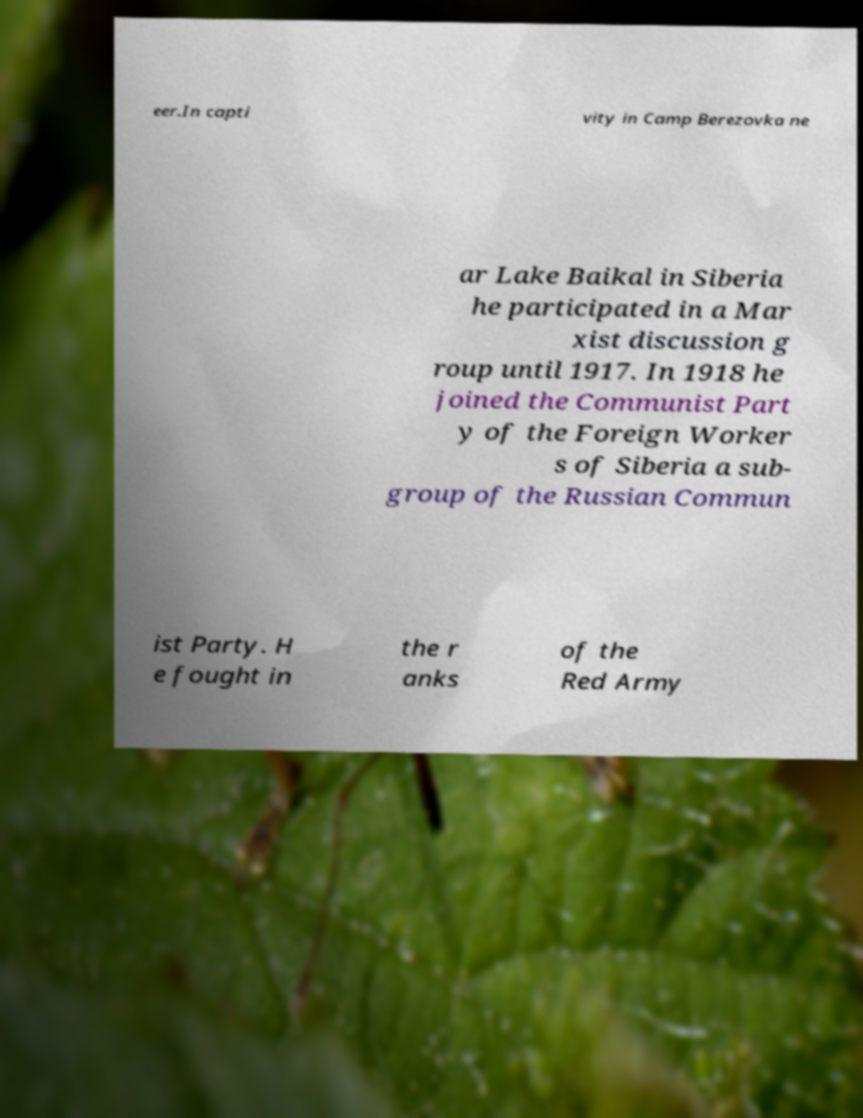What messages or text are displayed in this image? I need them in a readable, typed format. eer.In capti vity in Camp Berezovka ne ar Lake Baikal in Siberia he participated in a Mar xist discussion g roup until 1917. In 1918 he joined the Communist Part y of the Foreign Worker s of Siberia a sub- group of the Russian Commun ist Party. H e fought in the r anks of the Red Army 